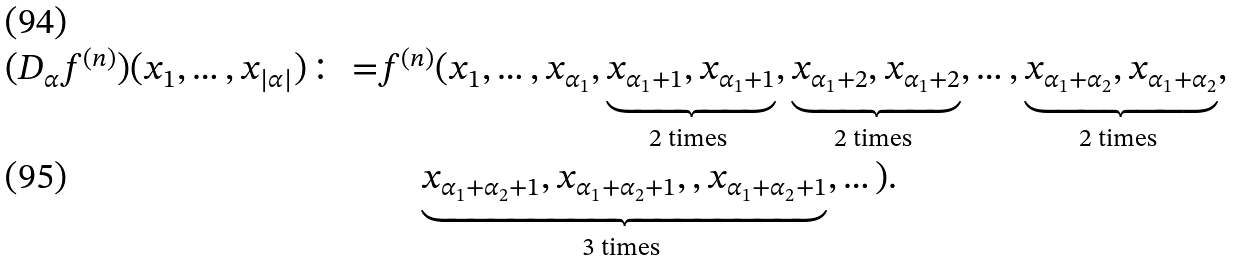Convert formula to latex. <formula><loc_0><loc_0><loc_500><loc_500>( D _ { \alpha } f ^ { ( n ) } ) ( x _ { 1 } , \dots , x _ { | \alpha | } ) { \colon = } & f ^ { ( n ) } ( x _ { 1 } , \dots , x _ { \alpha _ { 1 } } , \underbrace { x _ { \alpha _ { 1 } + 1 } , x _ { \alpha _ { 1 } + 1 } } _ { \text {2 times } } , \underbrace { x _ { \alpha _ { 1 } + 2 } , x _ { \alpha _ { 1 } + 2 } } _ { \text {2 times } } , \dots , \underbrace { x _ { \alpha _ { 1 } + \alpha _ { 2 } } , x _ { \alpha _ { 1 } + \alpha _ { 2 } } } _ { \text {2 times } } , \\ & \quad \underbrace { x _ { \alpha _ { 1 } + \alpha _ { 2 } + 1 } , x _ { \alpha _ { 1 } + \alpha _ { 2 } + 1 } , , x _ { \alpha _ { 1 } + \alpha _ { 2 } + 1 } } _ { \text {3 times } } , \dots ) .</formula> 